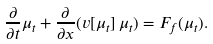<formula> <loc_0><loc_0><loc_500><loc_500>\frac { \partial } { \partial t } \mu _ { t } + \frac { \partial } { \partial x } ( v [ \mu _ { t } ] \, \mu _ { t } ) = F _ { f } ( \mu _ { t } ) .</formula> 